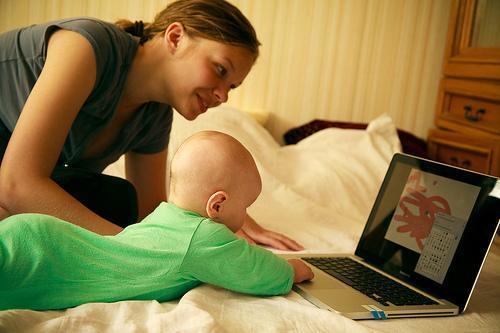How many people can you see?
Give a very brief answer. 2. How many people are between the two orange buses in the image?
Give a very brief answer. 0. 